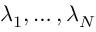<formula> <loc_0><loc_0><loc_500><loc_500>\lambda _ { 1 } , \dots , \lambda _ { N }</formula> 